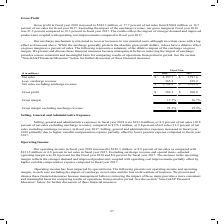According to Carpenter Technology's financial document, What was the gross profit in 2018? According to the financial document, $382.3 million. The relevant text states: "Gross profit in fiscal year 2018 increased to $382.3 million, or 17.7 percent of net sales from $300.8 million, or 16.7 percent of net sales for fiscal year 201..." Also, What was the gross profit in 2017 as a percentage of net sales? According to the financial document, 16.7 percent. The relevant text states: "17.7 percent of net sales from $300.8 million, or 16.7 percent of net sales for fiscal year 2017. Excluding the impact of the surcharge revenue, our gross margin..." Also, In which years was gross profit calculated? The document shows two values: 2018 and 2017. From the document: "Fiscal Year ($ in millions) 2018 2017 Net sales $ 2,157.7 $ 1,797.6 Less: surcharge revenue 365.4 239.2 Net sales excluding surcharge rev Fiscal Year ..." Additionally, In which year was the Gross margin excluding surcharge revenue larger? According to the financial document, 2018. The relevant text states: "Fiscal Year ($ in millions) 2018 2017 Net sales $ 2,157.7 $ 1,797.6 Less: surcharge revenue 365.4 239.2 Net sales excluding surcharg..." Also, can you calculate: What was the change in gross profit in 2018 from 2017? Based on the calculation: 382.3-300.8, the result is 81.5 (in millions). This is based on the information: "Gross profit in fiscal year 2018 increased to $382.3 million, or 17.7 percent of net sales from $300.8 million, or 16.7 percent of net sales for fiscal 382.3 million, or 17.7 percent of net sales from..." The key data points involved are: 300.8, 382.3. Also, can you calculate: What was the percentage change in gross profit in 2018 from 2017? To answer this question, I need to perform calculations using the financial data. The calculation is: (382.3-300.8)/300.8, which equals 27.09 (percentage). This is based on the information: "Gross profit in fiscal year 2018 increased to $382.3 million, or 17.7 percent of net sales from $300.8 million, or 16.7 percent of net sales for fiscal 382.3 million, or 17.7 percent of net sales from..." The key data points involved are: 300.8, 382.3. 